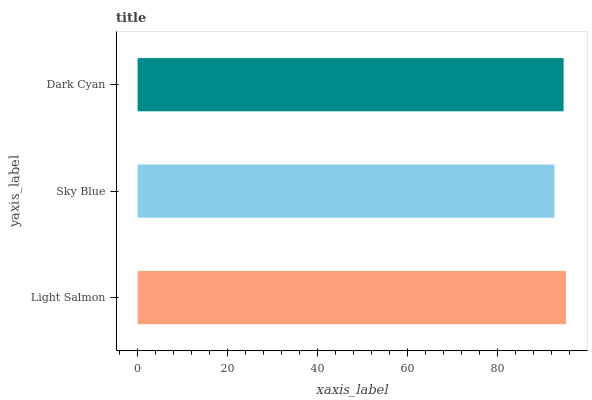Is Sky Blue the minimum?
Answer yes or no. Yes. Is Light Salmon the maximum?
Answer yes or no. Yes. Is Dark Cyan the minimum?
Answer yes or no. No. Is Dark Cyan the maximum?
Answer yes or no. No. Is Dark Cyan greater than Sky Blue?
Answer yes or no. Yes. Is Sky Blue less than Dark Cyan?
Answer yes or no. Yes. Is Sky Blue greater than Dark Cyan?
Answer yes or no. No. Is Dark Cyan less than Sky Blue?
Answer yes or no. No. Is Dark Cyan the high median?
Answer yes or no. Yes. Is Dark Cyan the low median?
Answer yes or no. Yes. Is Sky Blue the high median?
Answer yes or no. No. Is Light Salmon the low median?
Answer yes or no. No. 